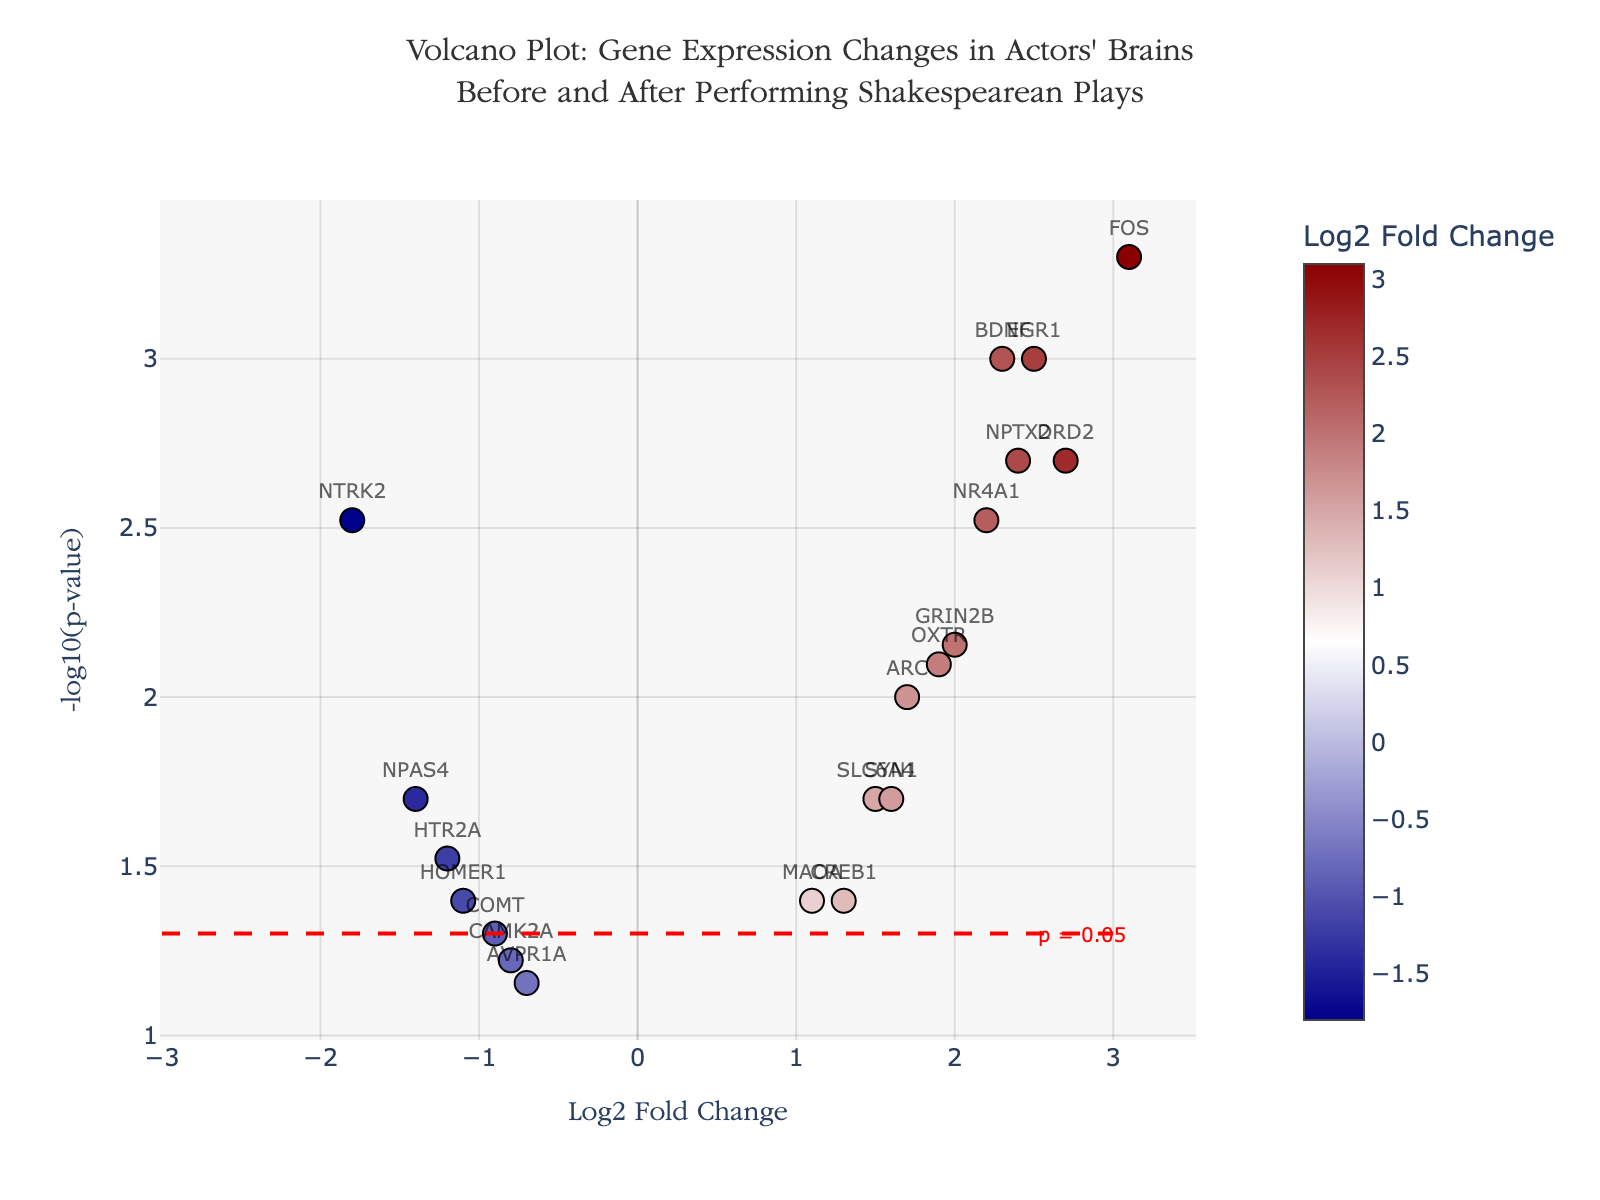What is the title of the plot? The title is positioned at the top of the figure. It reads, "Volcano Plot: Gene Expression Changes in Actors' Brains Before and After Performing Shakespearean Plays."
Answer: Volcano Plot: Gene Expression Changes in Actors' Brains Before and After Performing Shakespearean Plays What are the labels on the x-axis and y-axis? The labels on the axes are clearly marked. The x-axis is labeled "Log2 Fold Change," and the y-axis is labeled "-log10(p-value)."
Answer: Log2 Fold Change and -log10(p-value) How many genes are plotted in the Volcano Plot? By counting the text labels (gene names) displayed for each marker, it is clear that there are 19 genes in total.
Answer: 19 Which gene has the highest Log2 Fold Change, and what is its value? The gene with the highest Log2 Fold Change can be seen by identifying the marker furthest to the right on the x-axis, which is FOS with a Log2 Fold Change of 3.1.
Answer: FOS, 3.1 Which gene corresponds to the lowest p-value, and what is that p-value? The gene with the lowest p-value has the highest value on the y-axis. The gene FOS appears at the top, having a p-value of 0.0005.
Answer: FOS, 0.0005 How many genes have a p-value less than 0.05? We count the number of genes above the horizontal dashed red line, which indicates the significance threshold (p=0.05). There are 12 such genes.
Answer: 12 Which gene shows the most negative Log2 Fold Change, and what is its corresponding p-value? The most negative Log2 Fold Change is represented by the marker farthest to the left on the x-axis. This gene is NTRK2 with a Log2 Fold Change of -1.8 and a p-value of 0.003.
Answer: NTRK2, 0.003 How many genes have a Log2 Fold Change greater than 2? By looking at the points to the right of Log2 Fold Change value 2 on the x-axis, we count 5 genes (BDNF, DRD2, FOS, EGR1, and NPTX2).
Answer: 5 Which gene has a p-value just above 0.05? The gene close to but slightly below the horizontal threshold line (-log10(0.05)) is AVPR1A, with a p-value of 0.07.
Answer: AVPR1A Which genes have a Log2 Fold Change between 1 and 2 and a p-value less than 0.02? To answer this, we look for genes within the specified Log2 Fold Change range and below the threshold p-value on the y-axis. The genes are SLC6A4, ARC, and SYN1.
Answer: SLC6A4, ARC, SYN1 